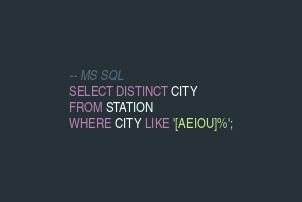<code> <loc_0><loc_0><loc_500><loc_500><_SQL_>-- MS SQL
SELECT DISTINCT CITY
FROM STATION
WHERE CITY LIKE '[AEIOU]%';</code> 